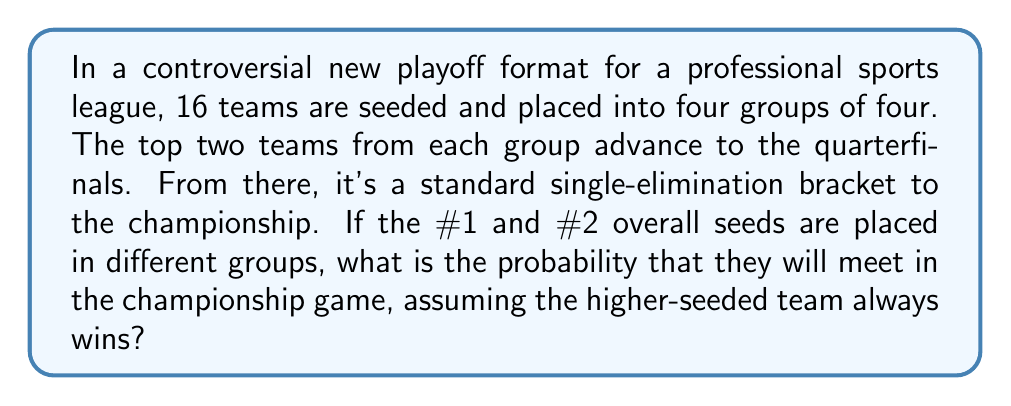Help me with this question. Let's approach this step-by-step:

1) First, we need to understand the structure of the tournament:
   - 16 teams in 4 groups of 4
   - Top 2 from each group advance (8 teams total)
   - Single-elimination bracket from quarterfinals onward

2) We're told that the #1 and #2 seeds are in different groups and that the higher-seeded team always wins. This means both will certainly make it to the quarterfinals.

3) For them to meet in the championship, they must be on opposite sides of the bracket in the quarterfinals. There are two possible scenarios:

   Scenario A: #1 seed on top half, #2 seed on bottom half
   Scenario B: #1 seed on bottom half, #2 seed on top half

4) The probability of each scenario is $\frac{1}{2}$, as there are two ways to arrange the #1 and #2 seeds in the bracket.

5) If they are on opposite halves, they will definitely meet in the final, as they will always win their matches (given that the higher-seeded team always wins).

6) Therefore, the probability of them meeting in the championship is equal to the probability of them being placed on opposite halves of the bracket in the quarterfinals, which is $\frac{1}{2}$.

This can be expressed mathematically as:

$$P(\text{#1 and #2 meet in final}) = P(\text{Scenario A}) + P(\text{Scenario B}) = \frac{1}{2} + \frac{1}{2} = 1$$
Answer: $\frac{1}{2}$ or $0.5$ or $50\%$ 